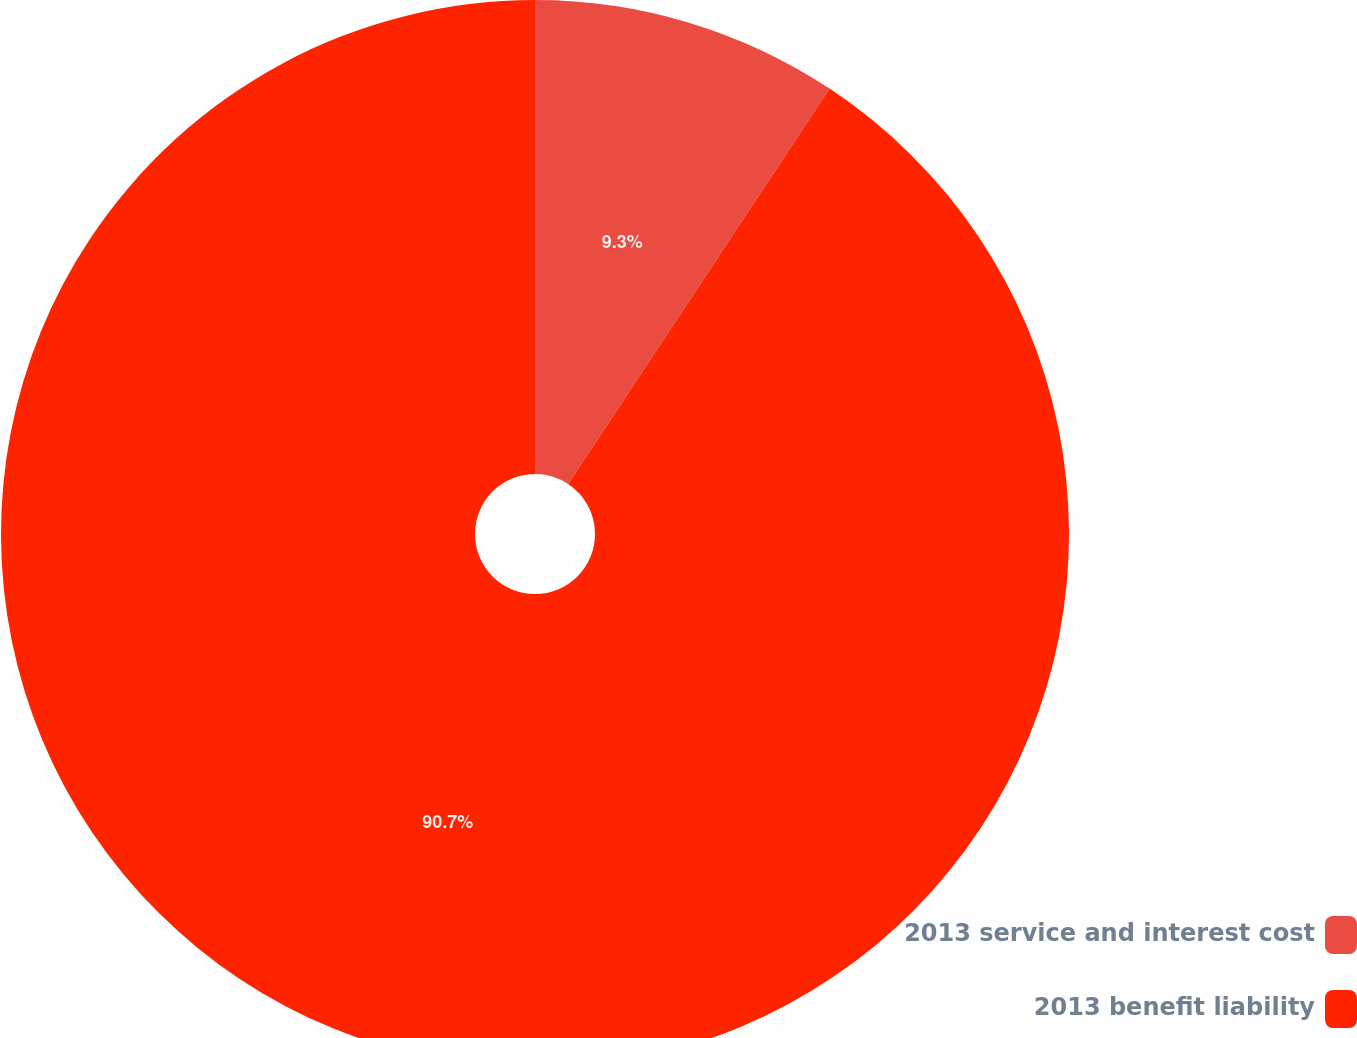Convert chart. <chart><loc_0><loc_0><loc_500><loc_500><pie_chart><fcel>2013 service and interest cost<fcel>2013 benefit liability<nl><fcel>9.3%<fcel>90.7%<nl></chart> 